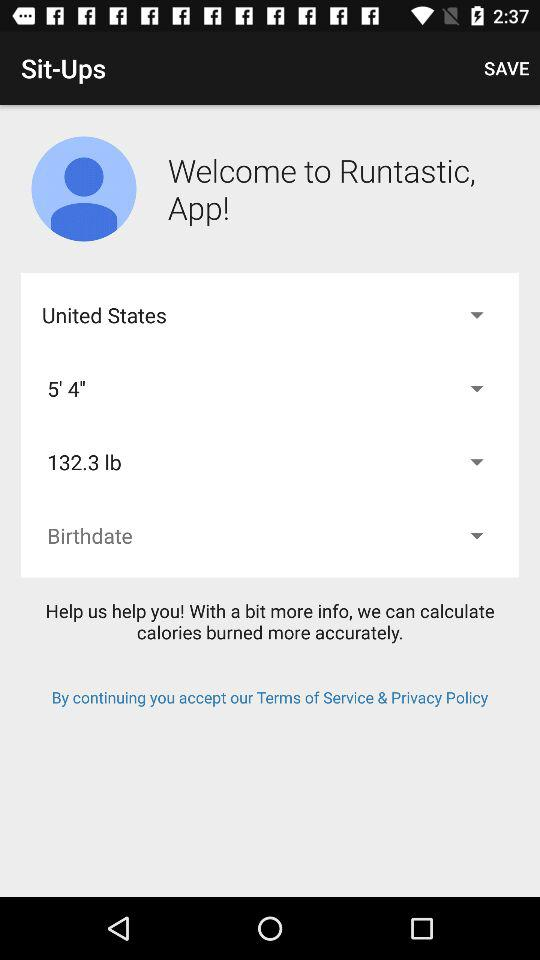What’s the app name? The app name is "Runtastic". 